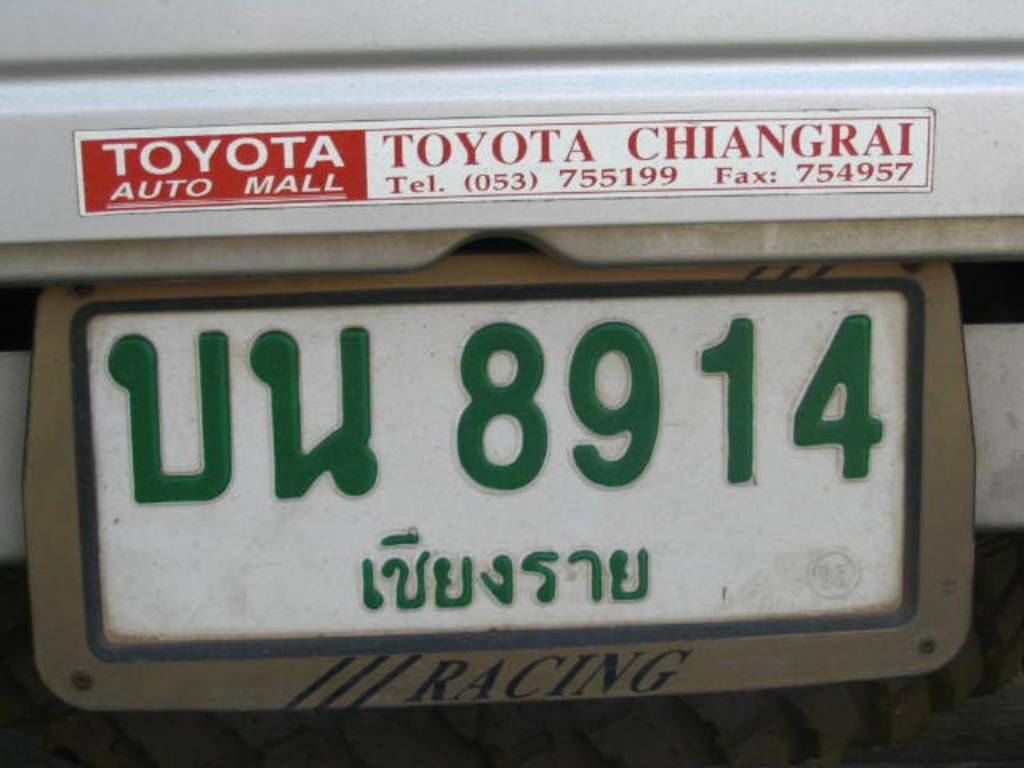What can be seen on the metal board in the image? There is a number plate and a sticker on the metal board in the image. What is the color of the metal board? The metal board is silver in color. Is there a heart-shaped sticker on the metal board in the image? No, there is no heart-shaped sticker on the metal board in the image; it only has a regular sticker. 